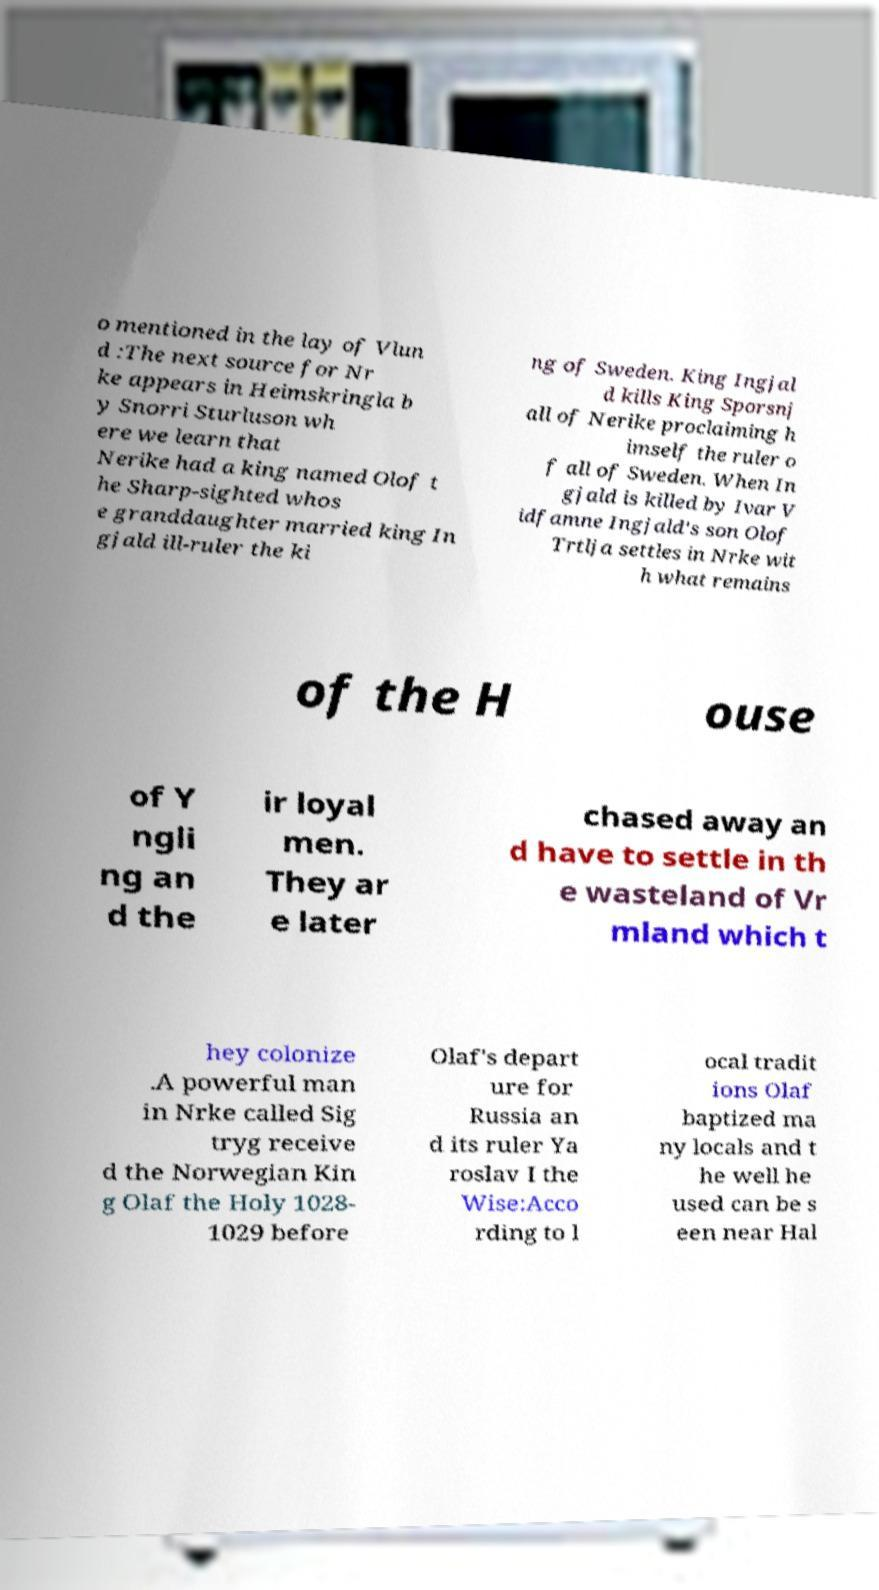I need the written content from this picture converted into text. Can you do that? o mentioned in the lay of Vlun d :The next source for Nr ke appears in Heimskringla b y Snorri Sturluson wh ere we learn that Nerike had a king named Olof t he Sharp-sighted whos e granddaughter married king In gjald ill-ruler the ki ng of Sweden. King Ingjal d kills King Sporsnj all of Nerike proclaiming h imself the ruler o f all of Sweden. When In gjald is killed by Ivar V idfamne Ingjald's son Olof Trtlja settles in Nrke wit h what remains of the H ouse of Y ngli ng an d the ir loyal men. They ar e later chased away an d have to settle in th e wasteland of Vr mland which t hey colonize .A powerful man in Nrke called Sig tryg receive d the Norwegian Kin g Olaf the Holy 1028- 1029 before Olaf's depart ure for Russia an d its ruler Ya roslav I the Wise:Acco rding to l ocal tradit ions Olaf baptized ma ny locals and t he well he used can be s een near Hal 